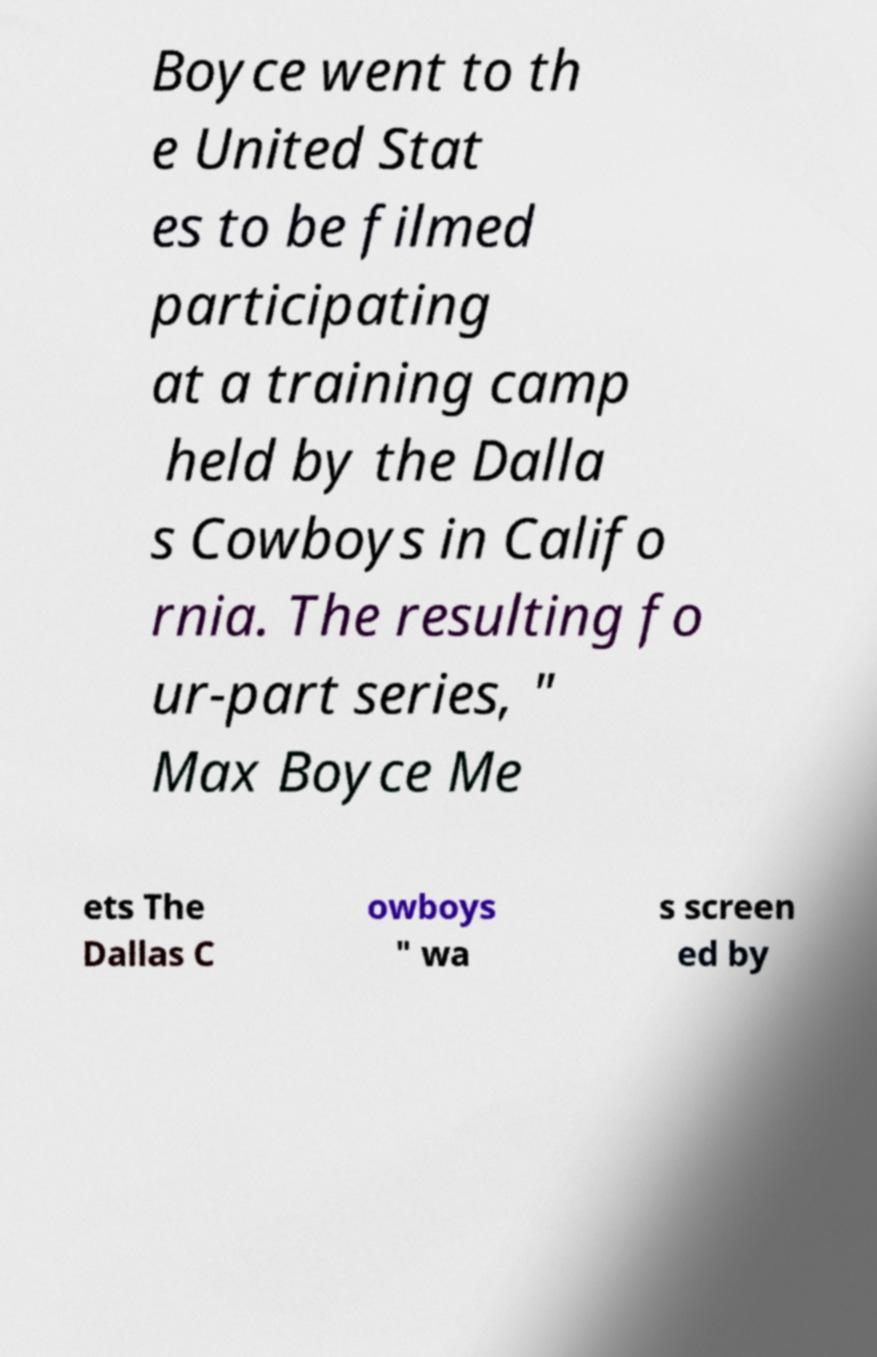Please identify and transcribe the text found in this image. Boyce went to th e United Stat es to be filmed participating at a training camp held by the Dalla s Cowboys in Califo rnia. The resulting fo ur-part series, " Max Boyce Me ets The Dallas C owboys " wa s screen ed by 